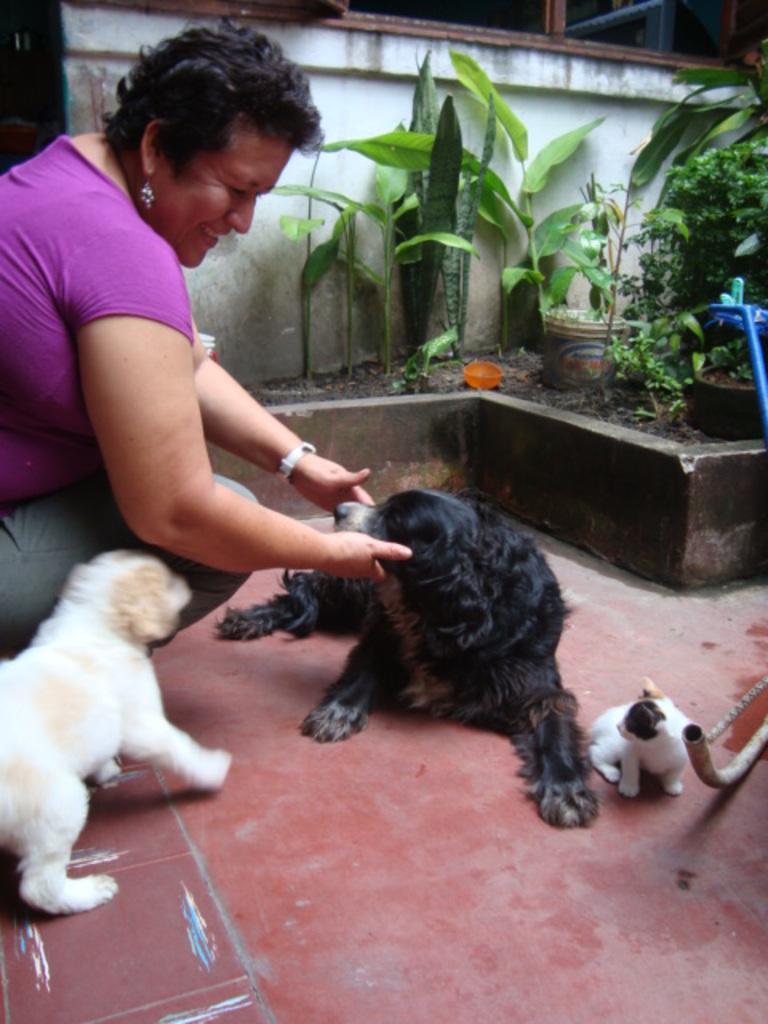Can you describe this image briefly? The woman in purple T-shirt who is in squad position is holding the face of the dog. She is smiling. In front of her, we see a black dog and a puppy. Beside her, we see a white dog. Behind her, there are plants and a wall in white color. 